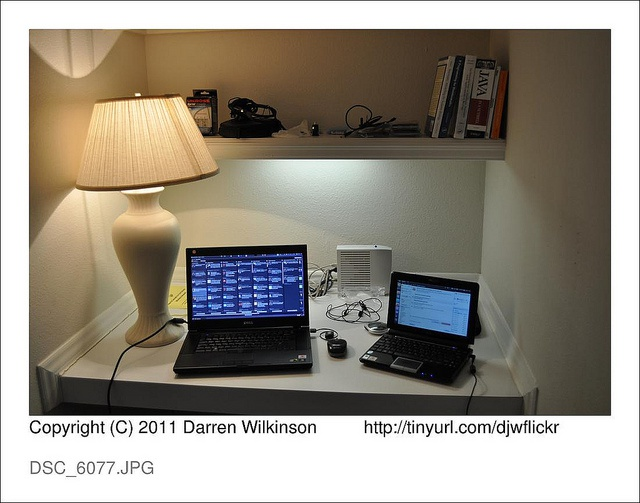Describe the objects in this image and their specific colors. I can see laptop in black, navy, blue, and darkblue tones, laptop in black and gray tones, book in black and gray tones, book in black and gray tones, and book in black and gray tones in this image. 